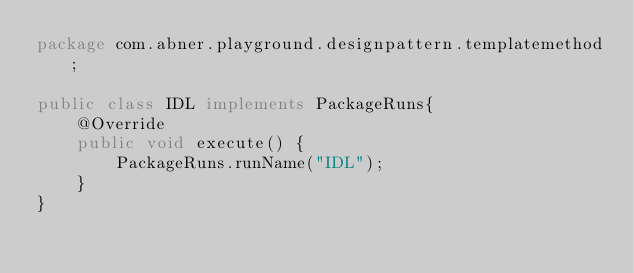Convert code to text. <code><loc_0><loc_0><loc_500><loc_500><_Java_>package com.abner.playground.designpattern.templatemethod;

public class IDL implements PackageRuns{
    @Override
    public void execute() {
        PackageRuns.runName("IDL");
    }
}
</code> 